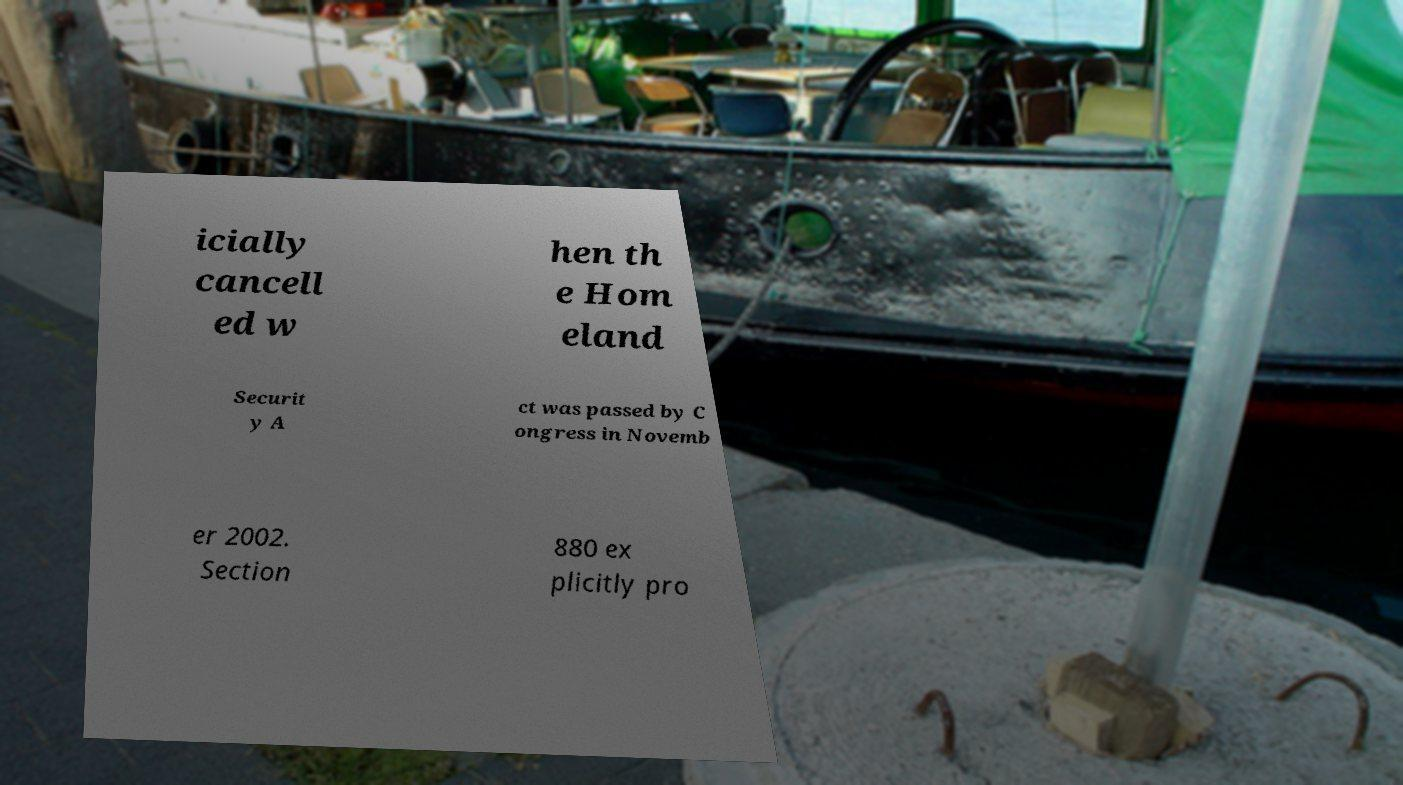Could you extract and type out the text from this image? icially cancell ed w hen th e Hom eland Securit y A ct was passed by C ongress in Novemb er 2002. Section 880 ex plicitly pro 